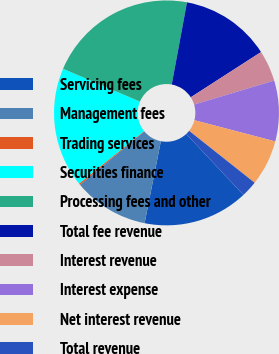<chart> <loc_0><loc_0><loc_500><loc_500><pie_chart><fcel>Servicing fees<fcel>Management fees<fcel>Trading services<fcel>Securities finance<fcel>Processing fees and other<fcel>Total fee revenue<fcel>Interest revenue<fcel>Interest expense<fcel>Net interest revenue<fcel>Total revenue<nl><fcel>15.11%<fcel>10.85%<fcel>0.21%<fcel>17.24%<fcel>21.5%<fcel>12.98%<fcel>4.46%<fcel>8.72%<fcel>6.59%<fcel>2.34%<nl></chart> 